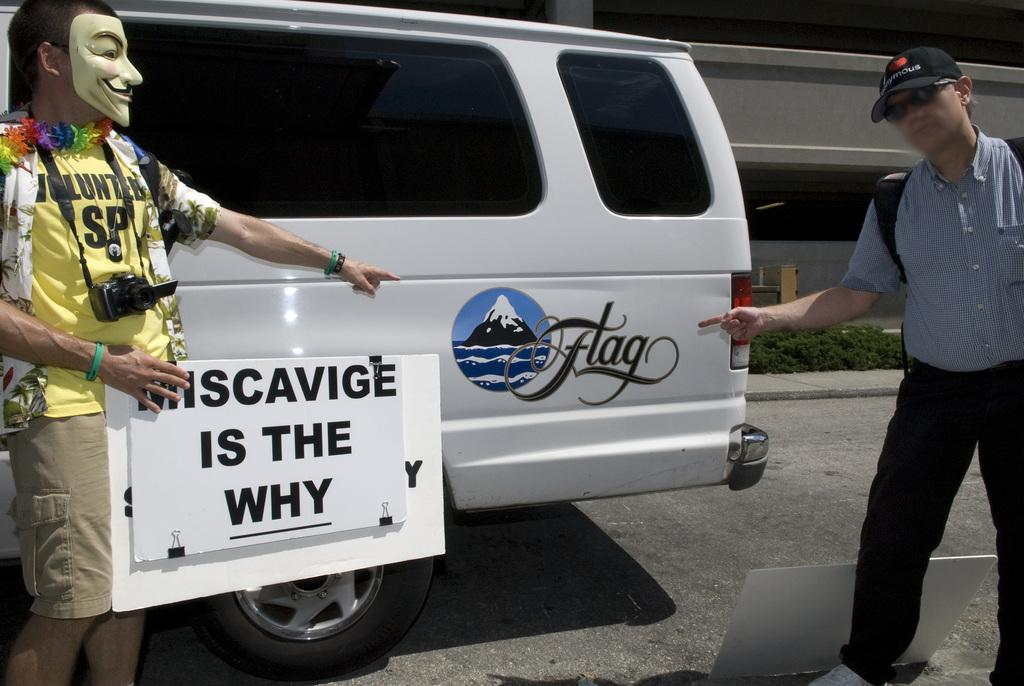<image>
Present a compact description of the photo's key features. Two people are pointing to a decal of a snowy mountain on a van that says Flag. 